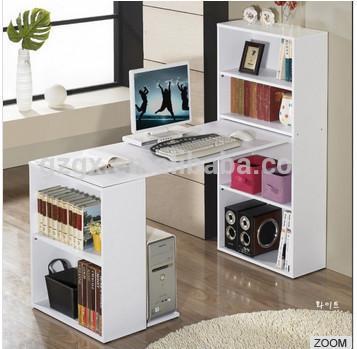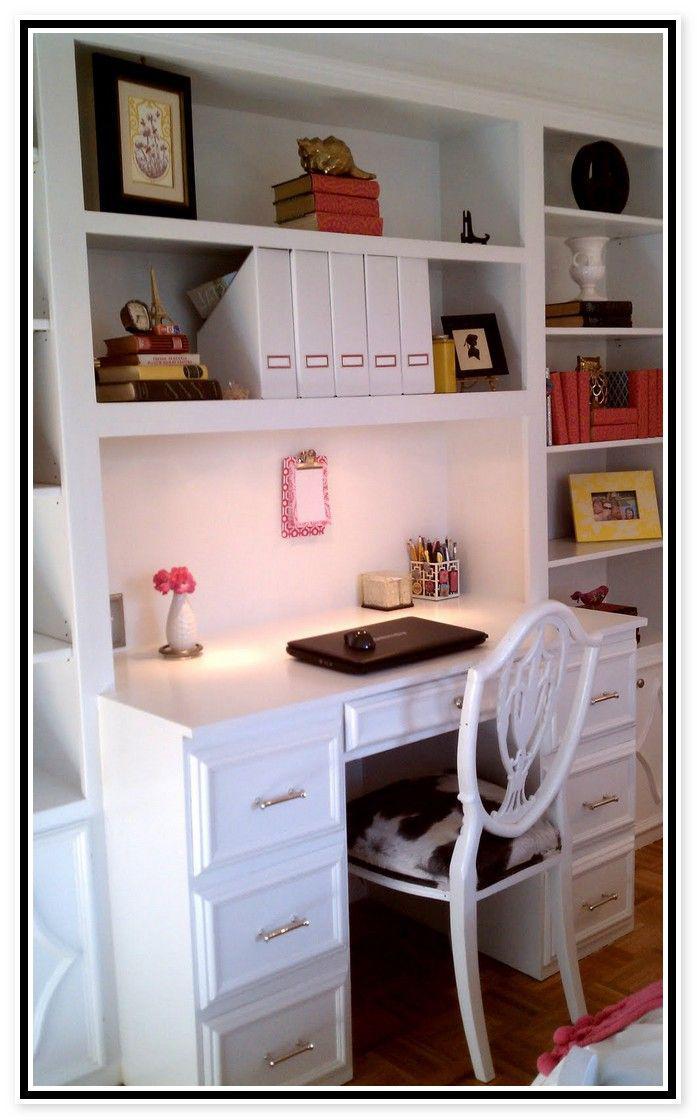The first image is the image on the left, the second image is the image on the right. Evaluate the accuracy of this statement regarding the images: "there is a built in desk and wall shelves with a desk chair at the desk". Is it true? Answer yes or no. Yes. 